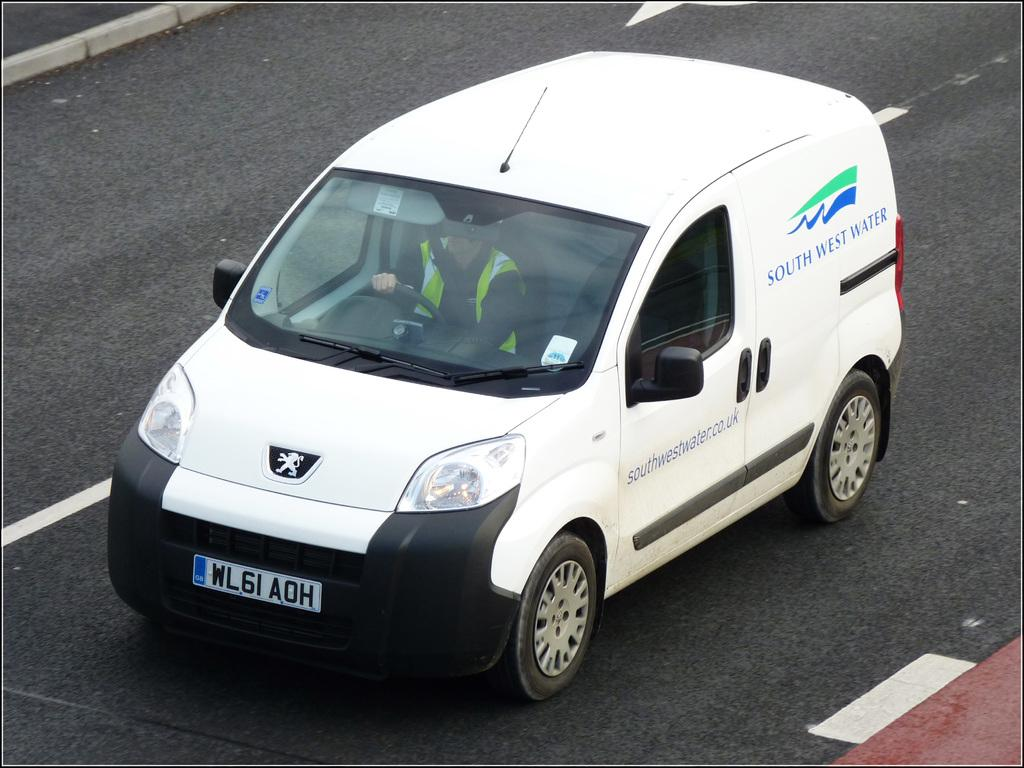<image>
Present a compact description of the photo's key features. A white South West Water van is being driven by a driver in a yellow vest. 